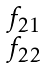Convert formula to latex. <formula><loc_0><loc_0><loc_500><loc_500>\begin{smallmatrix} f _ { 2 1 } \\ f _ { 2 2 } \end{smallmatrix}</formula> 